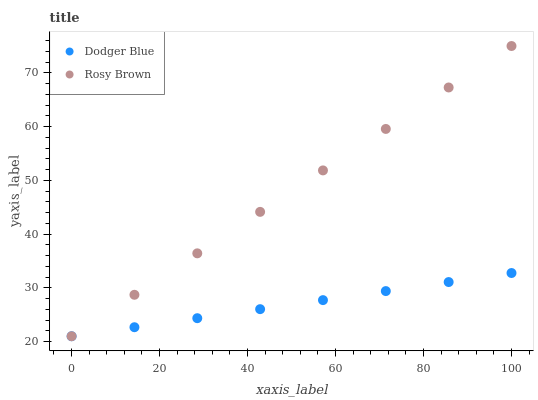Does Dodger Blue have the minimum area under the curve?
Answer yes or no. Yes. Does Rosy Brown have the maximum area under the curve?
Answer yes or no. Yes. Does Dodger Blue have the maximum area under the curve?
Answer yes or no. No. Is Dodger Blue the smoothest?
Answer yes or no. Yes. Is Rosy Brown the roughest?
Answer yes or no. Yes. Is Dodger Blue the roughest?
Answer yes or no. No. Does Rosy Brown have the lowest value?
Answer yes or no. Yes. Does Rosy Brown have the highest value?
Answer yes or no. Yes. Does Dodger Blue have the highest value?
Answer yes or no. No. Does Dodger Blue intersect Rosy Brown?
Answer yes or no. Yes. Is Dodger Blue less than Rosy Brown?
Answer yes or no. No. Is Dodger Blue greater than Rosy Brown?
Answer yes or no. No. 